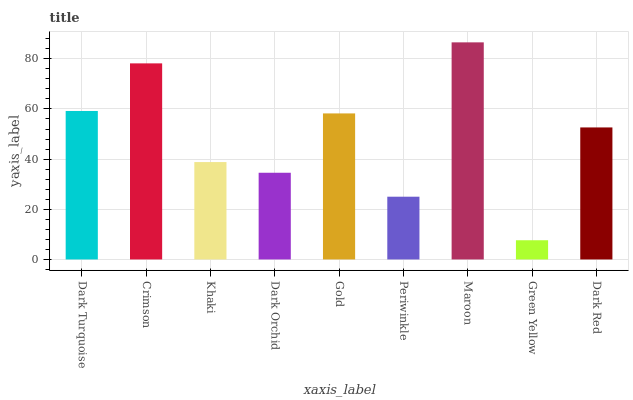Is Green Yellow the minimum?
Answer yes or no. Yes. Is Maroon the maximum?
Answer yes or no. Yes. Is Crimson the minimum?
Answer yes or no. No. Is Crimson the maximum?
Answer yes or no. No. Is Crimson greater than Dark Turquoise?
Answer yes or no. Yes. Is Dark Turquoise less than Crimson?
Answer yes or no. Yes. Is Dark Turquoise greater than Crimson?
Answer yes or no. No. Is Crimson less than Dark Turquoise?
Answer yes or no. No. Is Dark Red the high median?
Answer yes or no. Yes. Is Dark Red the low median?
Answer yes or no. Yes. Is Dark Orchid the high median?
Answer yes or no. No. Is Crimson the low median?
Answer yes or no. No. 